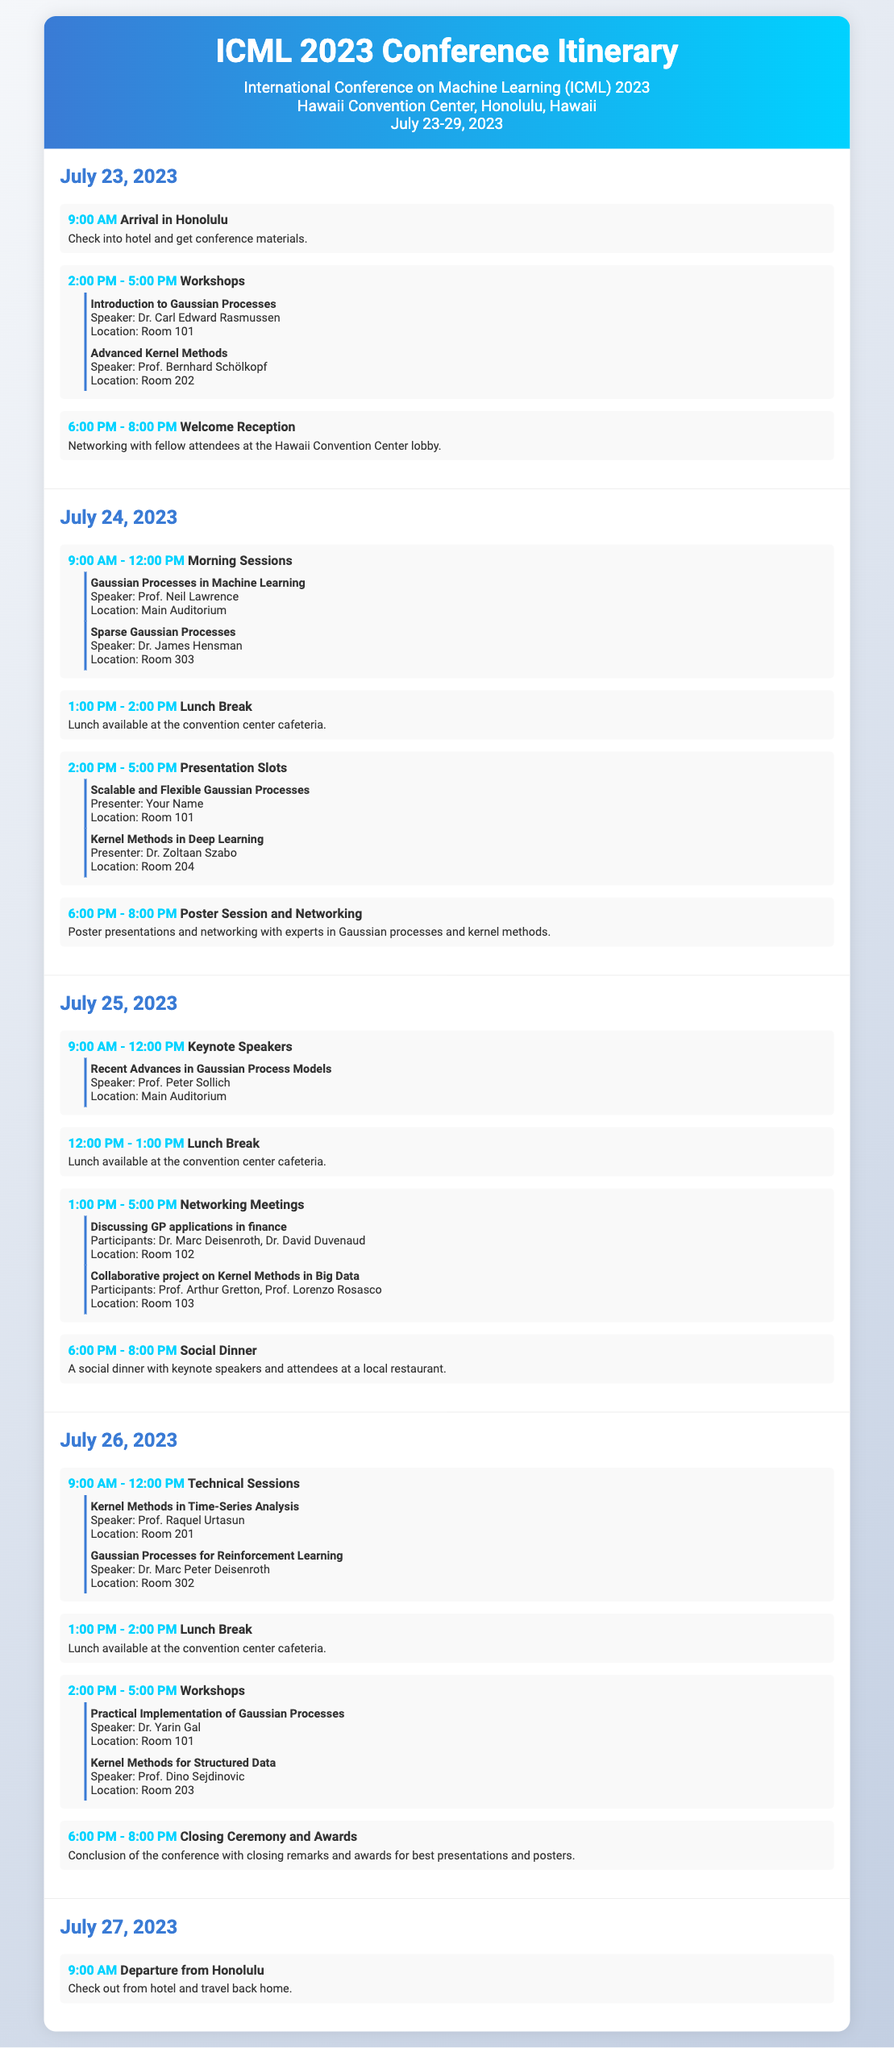what is the duration of the conference? The conference spans from July 23 to July 29, 2023, covering a total of 7 days.
Answer: 7 days who is the speaker for the workshop on "Introduction to Gaussian Processes"? The document lists Dr. Carl Edward Rasmussen as the speaker for this workshop.
Answer: Dr. Carl Edward Rasmussen what time does the Welcome Reception start? According to the itinerary, the Welcome Reception is scheduled to start at 6:00 PM.
Answer: 6:00 PM how many networking sessions are scheduled on July 24, 2023? There are two networking sessions scheduled on July 24, including a poster session and meetings.
Answer: 2 sessions which workshop focuses on "Kernel Methods for Structured Data"? The itinerary specifies that Prof. Dino Sejdinovic will present a workshop on this topic.
Answer: Prof. Dino Sejdinovic what is the location of the keynote speech on "Recent Advances in Gaussian Process Models"? The keynote speech by Prof. Peter Sollich will take place in the Main Auditorium.
Answer: Main Auditorium who presents the session on "Scalable and Flexible Gaussian Processes"? The document indicates that you will be the presenter for this session.
Answer: Your Name when is the Closing Ceremony and Awards scheduled? The Closing Ceremony and Awards will take place on July 26, 2023, at 6:00 PM.
Answer: July 26, 2023, 6:00 PM what is the final event listed in the itinerary? The last event in the itinerary is the departure from Honolulu, set for July 27, 2023.
Answer: Departure from Honolulu 